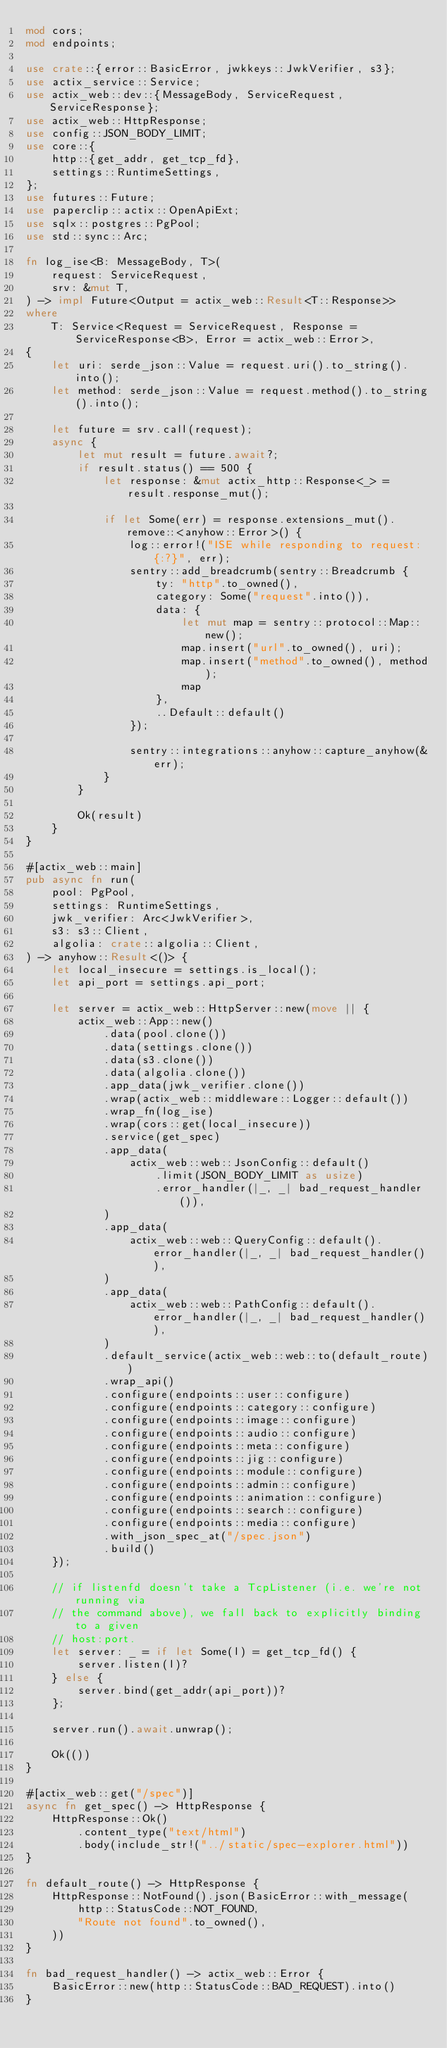Convert code to text. <code><loc_0><loc_0><loc_500><loc_500><_Rust_>mod cors;
mod endpoints;

use crate::{error::BasicError, jwkkeys::JwkVerifier, s3};
use actix_service::Service;
use actix_web::dev::{MessageBody, ServiceRequest, ServiceResponse};
use actix_web::HttpResponse;
use config::JSON_BODY_LIMIT;
use core::{
    http::{get_addr, get_tcp_fd},
    settings::RuntimeSettings,
};
use futures::Future;
use paperclip::actix::OpenApiExt;
use sqlx::postgres::PgPool;
use std::sync::Arc;

fn log_ise<B: MessageBody, T>(
    request: ServiceRequest,
    srv: &mut T,
) -> impl Future<Output = actix_web::Result<T::Response>>
where
    T: Service<Request = ServiceRequest, Response = ServiceResponse<B>, Error = actix_web::Error>,
{
    let uri: serde_json::Value = request.uri().to_string().into();
    let method: serde_json::Value = request.method().to_string().into();

    let future = srv.call(request);
    async {
        let mut result = future.await?;
        if result.status() == 500 {
            let response: &mut actix_http::Response<_> = result.response_mut();

            if let Some(err) = response.extensions_mut().remove::<anyhow::Error>() {
                log::error!("ISE while responding to request: {:?}", err);
                sentry::add_breadcrumb(sentry::Breadcrumb {
                    ty: "http".to_owned(),
                    category: Some("request".into()),
                    data: {
                        let mut map = sentry::protocol::Map::new();
                        map.insert("url".to_owned(), uri);
                        map.insert("method".to_owned(), method);
                        map
                    },
                    ..Default::default()
                });

                sentry::integrations::anyhow::capture_anyhow(&err);
            }
        }

        Ok(result)
    }
}

#[actix_web::main]
pub async fn run(
    pool: PgPool,
    settings: RuntimeSettings,
    jwk_verifier: Arc<JwkVerifier>,
    s3: s3::Client,
    algolia: crate::algolia::Client,
) -> anyhow::Result<()> {
    let local_insecure = settings.is_local();
    let api_port = settings.api_port;

    let server = actix_web::HttpServer::new(move || {
        actix_web::App::new()
            .data(pool.clone())
            .data(settings.clone())
            .data(s3.clone())
            .data(algolia.clone())
            .app_data(jwk_verifier.clone())
            .wrap(actix_web::middleware::Logger::default())
            .wrap_fn(log_ise)
            .wrap(cors::get(local_insecure))
            .service(get_spec)
            .app_data(
                actix_web::web::JsonConfig::default()
                    .limit(JSON_BODY_LIMIT as usize)
                    .error_handler(|_, _| bad_request_handler()),
            )
            .app_data(
                actix_web::web::QueryConfig::default().error_handler(|_, _| bad_request_handler()),
            )
            .app_data(
                actix_web::web::PathConfig::default().error_handler(|_, _| bad_request_handler()),
            )
            .default_service(actix_web::web::to(default_route))
            .wrap_api()
            .configure(endpoints::user::configure)
            .configure(endpoints::category::configure)
            .configure(endpoints::image::configure)
            .configure(endpoints::audio::configure)
            .configure(endpoints::meta::configure)
            .configure(endpoints::jig::configure)
            .configure(endpoints::module::configure)
            .configure(endpoints::admin::configure)
            .configure(endpoints::animation::configure)
            .configure(endpoints::search::configure)
            .configure(endpoints::media::configure)
            .with_json_spec_at("/spec.json")
            .build()
    });

    // if listenfd doesn't take a TcpListener (i.e. we're not running via
    // the command above), we fall back to explicitly binding to a given
    // host:port.
    let server: _ = if let Some(l) = get_tcp_fd() {
        server.listen(l)?
    } else {
        server.bind(get_addr(api_port))?
    };

    server.run().await.unwrap();

    Ok(())
}

#[actix_web::get("/spec")]
async fn get_spec() -> HttpResponse {
    HttpResponse::Ok()
        .content_type("text/html")
        .body(include_str!("../static/spec-explorer.html"))
}

fn default_route() -> HttpResponse {
    HttpResponse::NotFound().json(BasicError::with_message(
        http::StatusCode::NOT_FOUND,
        "Route not found".to_owned(),
    ))
}

fn bad_request_handler() -> actix_web::Error {
    BasicError::new(http::StatusCode::BAD_REQUEST).into()
}
</code> 